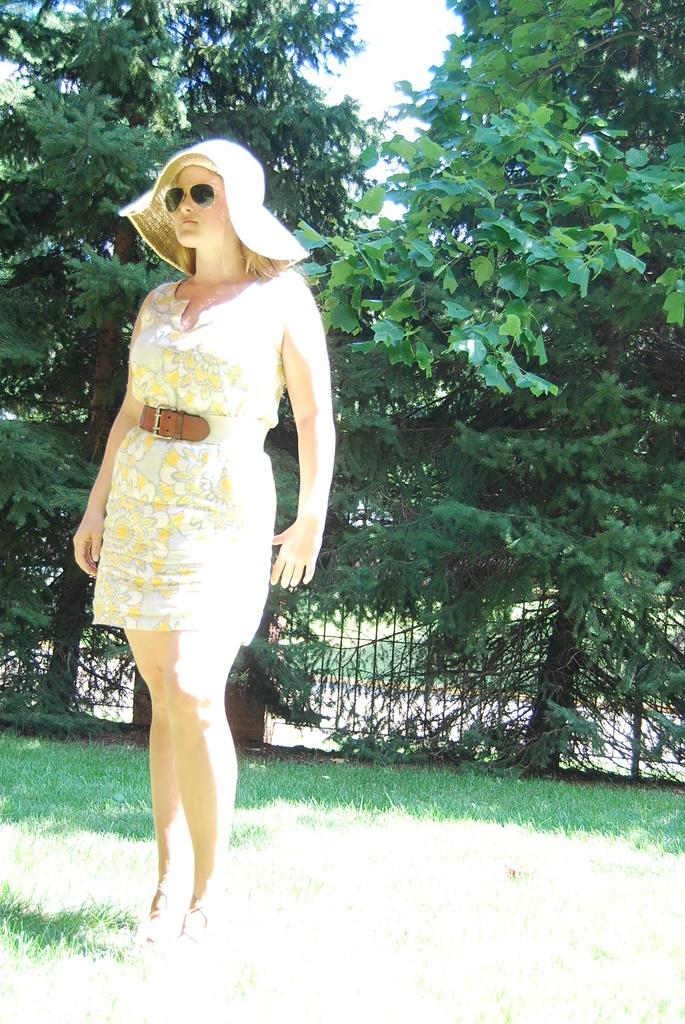Who is the main subject in the image? There is a lady in the image. What is the lady wearing on her head? The lady is wearing a hat. What accessory is the lady wearing on her face? The lady is wearing glasses. Where is the lady standing? The lady is standing on a grassland. What can be seen in the background of the image? There are trees and fencing in the background of the image. What type of quilt is the lady attempting to sew in the image? There is no quilt or sewing activity present in the image. 